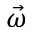<formula> <loc_0><loc_0><loc_500><loc_500>\vec { \omega }</formula> 